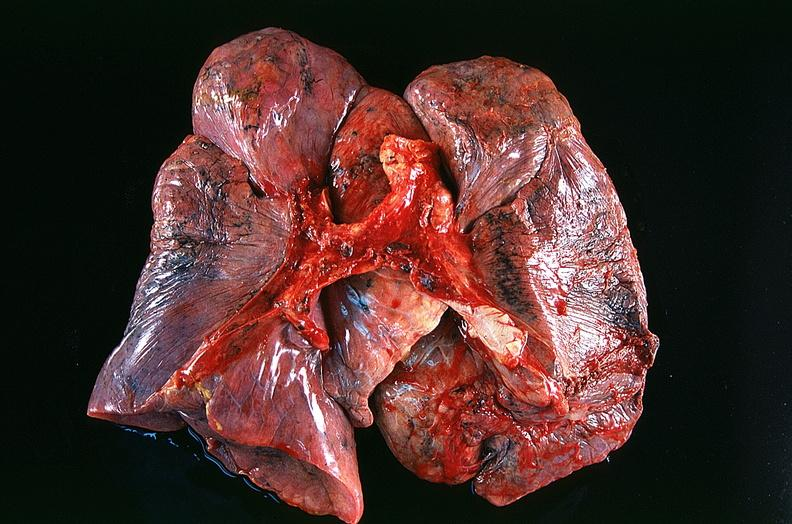what is present?
Answer the question using a single word or phrase. Respiratory 